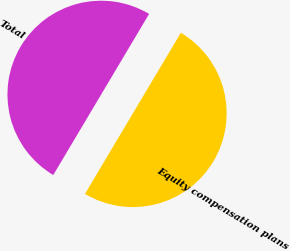Convert chart to OTSL. <chart><loc_0><loc_0><loc_500><loc_500><pie_chart><fcel>Equity compensation plans<fcel>Total<nl><fcel>50.0%<fcel>50.0%<nl></chart> 